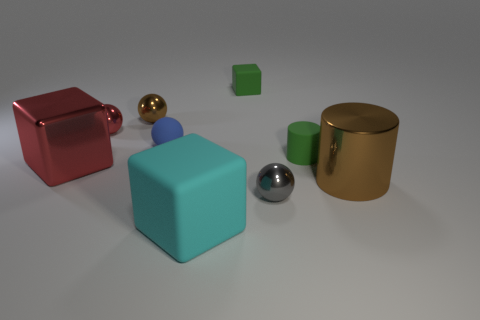Imagine this is a scene from a story. What could be happening here? In a creative narrative context, we could imagine these objects as characters or essential elements in a fantastical realm. The distinct shapes might represent different families or clans, with the spheres acting as oracle-like figures that reflect the past and future. The cylinders could serve as pillars of wisdom, while the cubes might be the homes or vessels that transport beings of this world. An interplay between the various elements might symbolize a harmony or conflict pivotal to the storyline. 